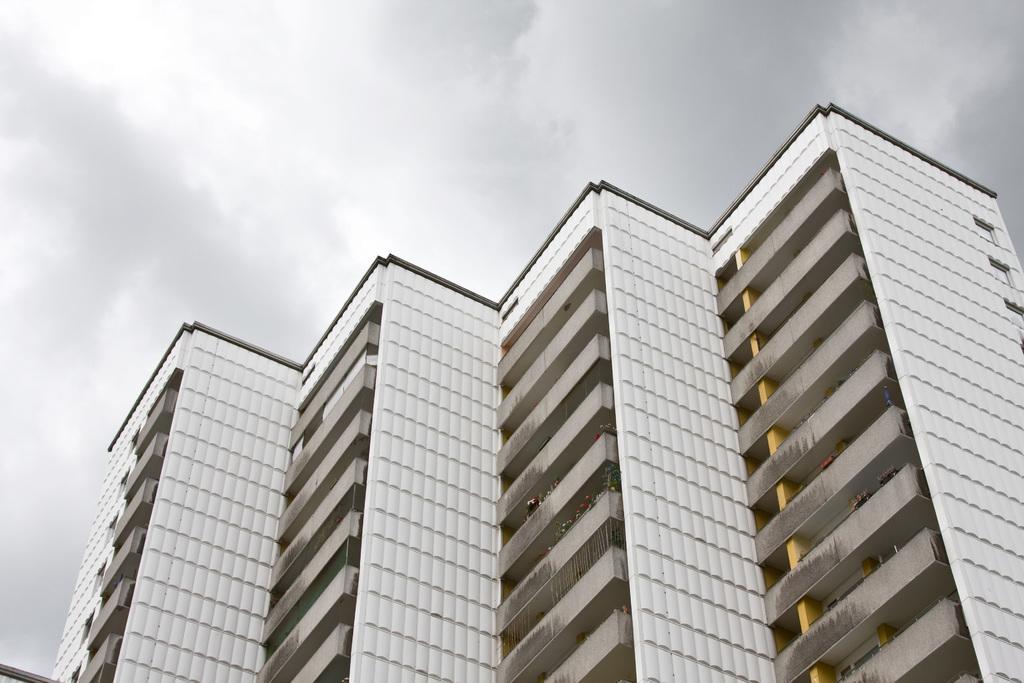Please provide a concise description of this image. In the center of the image, we can see buildings and at the top, there is a sky. 